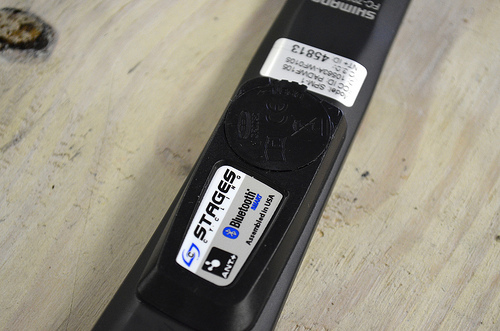<image>
Is the sticker on the remote? Yes. Looking at the image, I can see the sticker is positioned on top of the remote, with the remote providing support. 